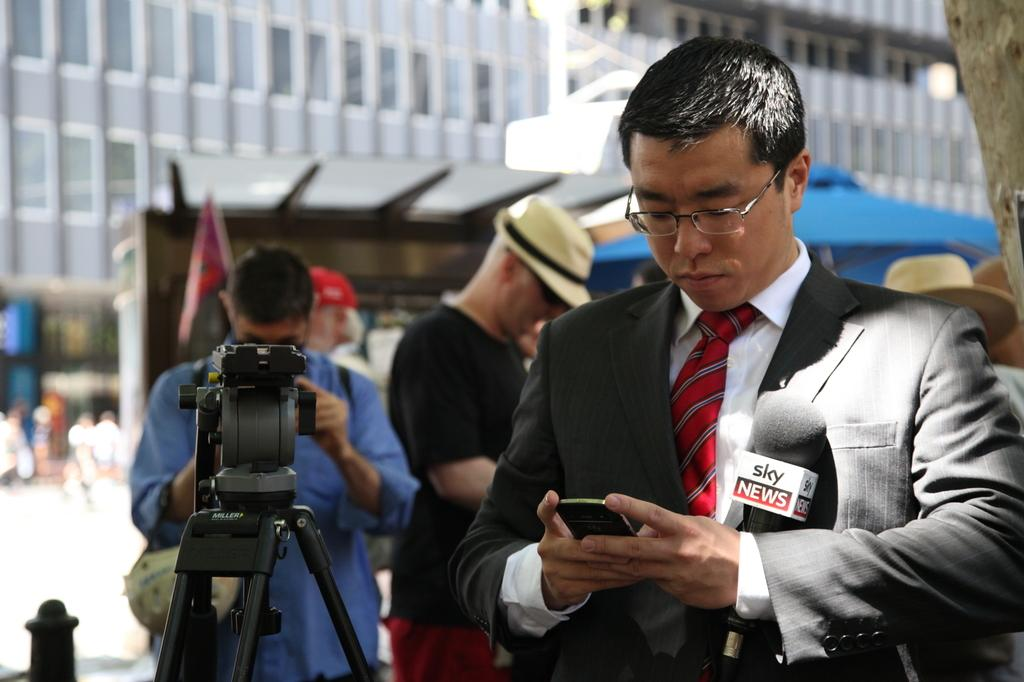What are the persons in the image holding? The persons in the image are holding mobile phones. What can be seen on the left side of the image? There is a video camera and persons on the left side of the image. What is visible in the background of the image? There is a flag, persons, a tree, and a road in the background of the image. Can you tell me how many lamps are visible in the image? There are no lamps present in the image. What type of worm can be seen crawling on the persons in the image? There are no worms present in the image. 